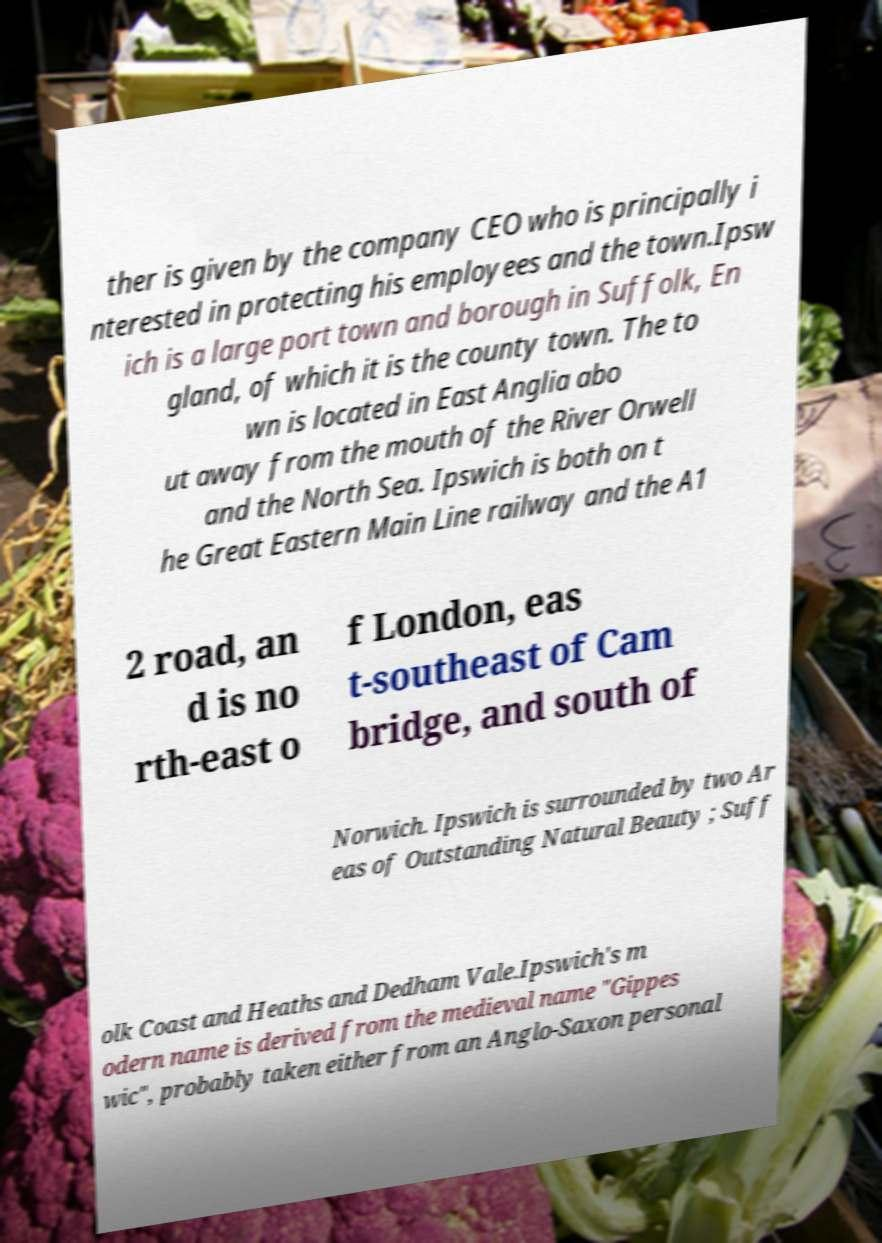Can you accurately transcribe the text from the provided image for me? ther is given by the company CEO who is principally i nterested in protecting his employees and the town.Ipsw ich is a large port town and borough in Suffolk, En gland, of which it is the county town. The to wn is located in East Anglia abo ut away from the mouth of the River Orwell and the North Sea. Ipswich is both on t he Great Eastern Main Line railway and the A1 2 road, an d is no rth-east o f London, eas t-southeast of Cam bridge, and south of Norwich. Ipswich is surrounded by two Ar eas of Outstanding Natural Beauty ; Suff olk Coast and Heaths and Dedham Vale.Ipswich's m odern name is derived from the medieval name "Gippes wic", probably taken either from an Anglo-Saxon personal 